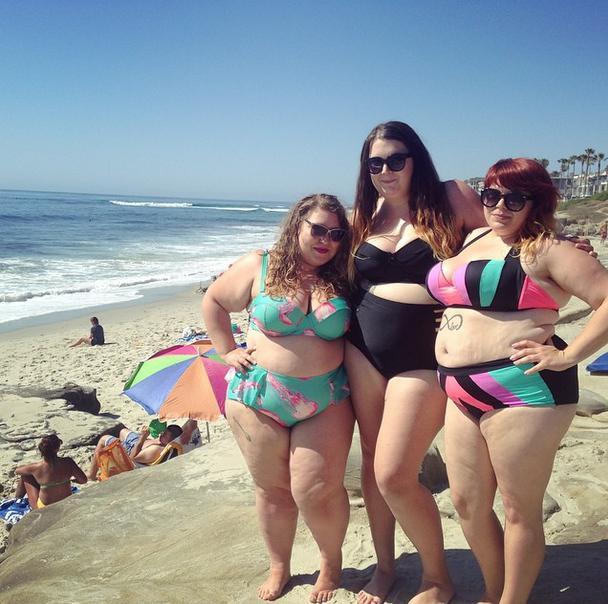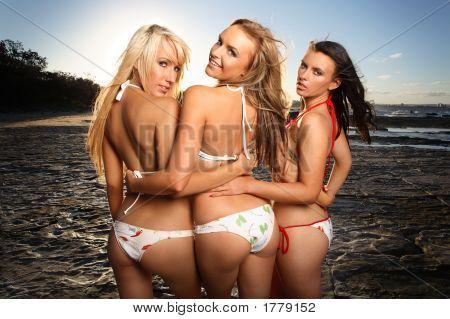The first image is the image on the left, the second image is the image on the right. Assess this claim about the two images: "The three women in bikinis in the image on the right are shown from behind.". Correct or not? Answer yes or no. Yes. The first image is the image on the left, the second image is the image on the right. Examine the images to the left and right. Is the description "An image shows three bikini models with their rears to the camera, standing with arms around each other." accurate? Answer yes or no. Yes. 